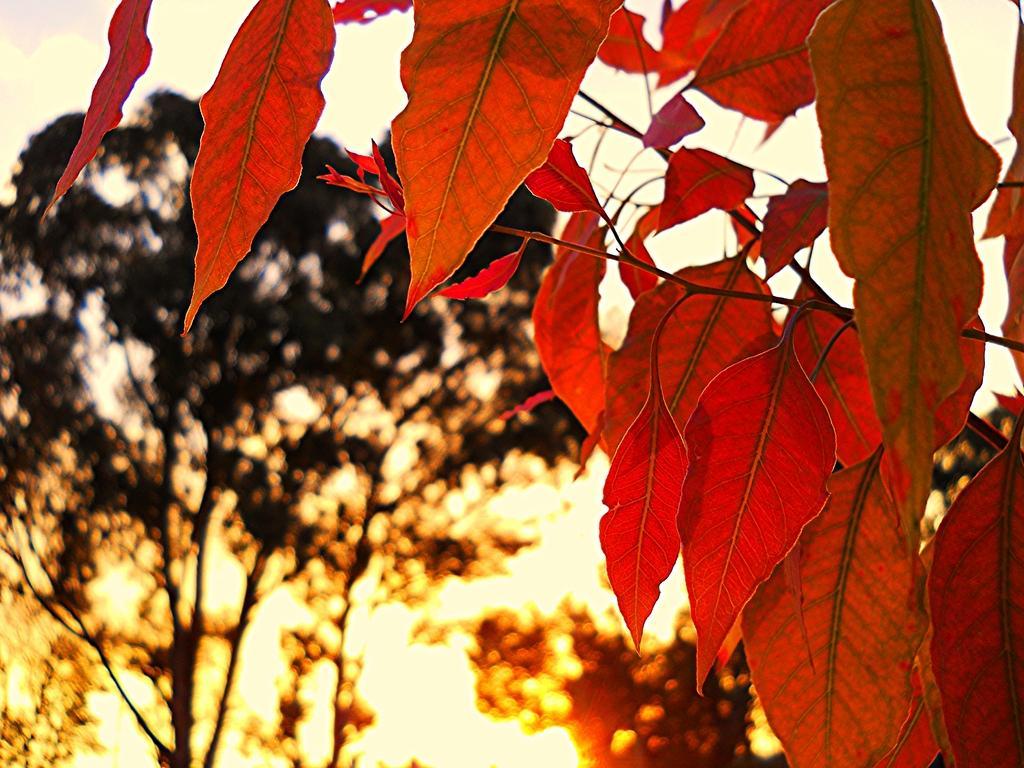Please provide a concise description of this image. This image consists of trees. On the right, we can see the leaves in red color. In the background, there is a sunlight. At the top, there is sky. 